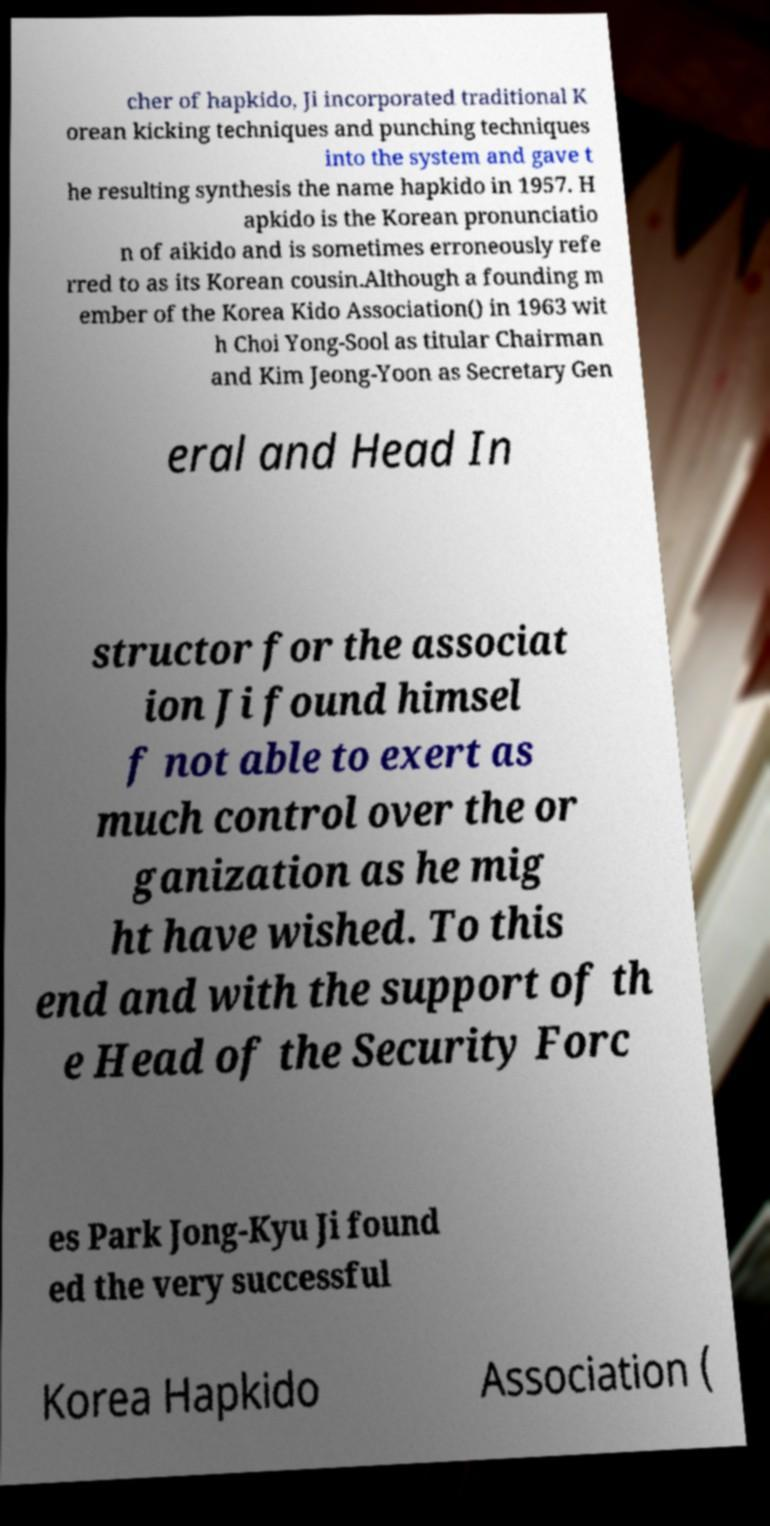What messages or text are displayed in this image? I need them in a readable, typed format. cher of hapkido, Ji incorporated traditional K orean kicking techniques and punching techniques into the system and gave t he resulting synthesis the name hapkido in 1957. H apkido is the Korean pronunciatio n of aikido and is sometimes erroneously refe rred to as its Korean cousin.Although a founding m ember of the Korea Kido Association() in 1963 wit h Choi Yong-Sool as titular Chairman and Kim Jeong-Yoon as Secretary Gen eral and Head In structor for the associat ion Ji found himsel f not able to exert as much control over the or ganization as he mig ht have wished. To this end and with the support of th e Head of the Security Forc es Park Jong-Kyu Ji found ed the very successful Korea Hapkido Association ( 